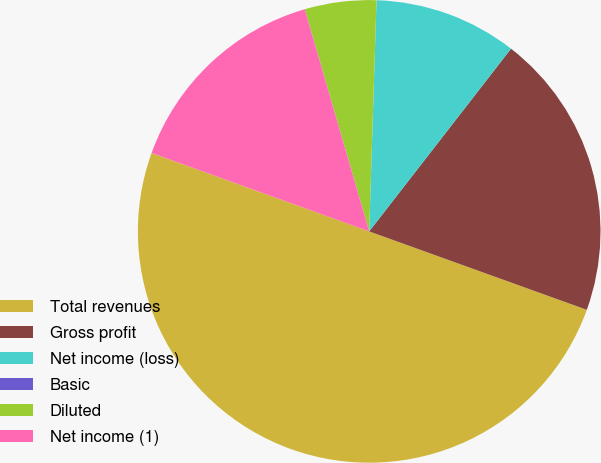Convert chart to OTSL. <chart><loc_0><loc_0><loc_500><loc_500><pie_chart><fcel>Total revenues<fcel>Gross profit<fcel>Net income (loss)<fcel>Basic<fcel>Diluted<fcel>Net income (1)<nl><fcel>50.0%<fcel>20.0%<fcel>10.0%<fcel>0.0%<fcel>5.0%<fcel>15.0%<nl></chart> 